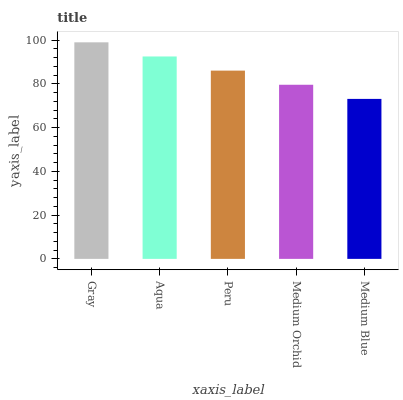Is Medium Blue the minimum?
Answer yes or no. Yes. Is Gray the maximum?
Answer yes or no. Yes. Is Aqua the minimum?
Answer yes or no. No. Is Aqua the maximum?
Answer yes or no. No. Is Gray greater than Aqua?
Answer yes or no. Yes. Is Aqua less than Gray?
Answer yes or no. Yes. Is Aqua greater than Gray?
Answer yes or no. No. Is Gray less than Aqua?
Answer yes or no. No. Is Peru the high median?
Answer yes or no. Yes. Is Peru the low median?
Answer yes or no. Yes. Is Medium Blue the high median?
Answer yes or no. No. Is Gray the low median?
Answer yes or no. No. 